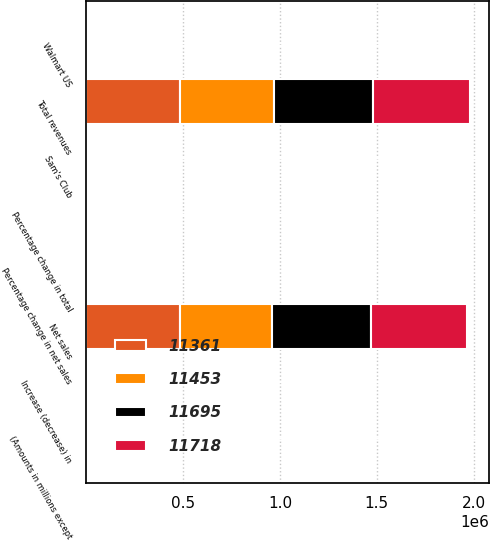Convert chart. <chart><loc_0><loc_0><loc_500><loc_500><stacked_bar_chart><ecel><fcel>(Amounts in millions except<fcel>Total revenues<fcel>Percentage change in total<fcel>Net sales<fcel>Percentage change in net sales<fcel>Increase (decrease) in<fcel>Walmart US<fcel>Sam's Club<nl><fcel>11695<fcel>2019<fcel>514405<fcel>2.8<fcel>510329<fcel>2.9<fcel>4<fcel>3.7<fcel>5.4<nl><fcel>11718<fcel>2018<fcel>500343<fcel>3<fcel>495761<fcel>3<fcel>2.2<fcel>2.1<fcel>2.8<nl><fcel>11361<fcel>2017<fcel>485873<fcel>0.8<fcel>481317<fcel>0.6<fcel>1.4<fcel>1.6<fcel>0.5<nl><fcel>11453<fcel>2016<fcel>482130<fcel>0.7<fcel>478614<fcel>0.7<fcel>0.3<fcel>1<fcel>3.2<nl></chart> 